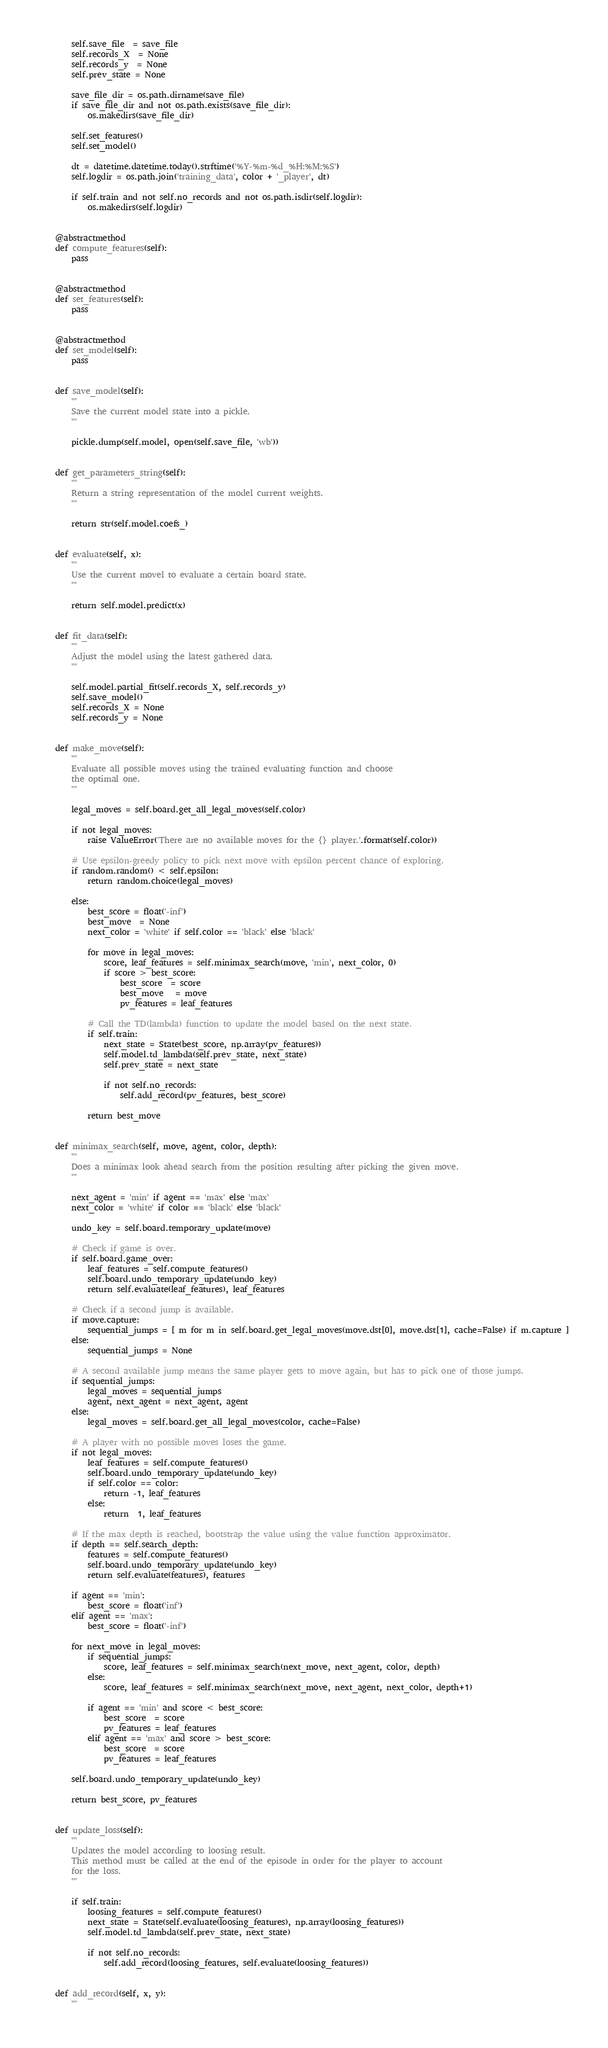<code> <loc_0><loc_0><loc_500><loc_500><_Python_>        self.save_file  = save_file
        self.records_X  = None
        self.records_y  = None
        self.prev_state = None

        save_file_dir = os.path.dirname(save_file)
        if save_file_dir and not os.path.exists(save_file_dir):
            os.makedirs(save_file_dir)

        self.set_features()
        self.set_model()

        dt = datetime.datetime.today().strftime('%Y-%m-%d_%H:%M:%S')
        self.logdir = os.path.join('training_data', color + '_player', dt)

        if self.train and not self.no_records and not os.path.isdir(self.logdir):
            os.makedirs(self.logdir)


    @abstractmethod
    def compute_features(self):
        pass

    
    @abstractmethod
    def set_features(self):
        pass


    @abstractmethod
    def set_model(self):
        pass 


    def save_model(self):
        '''
        Save the current model state into a pickle.
        '''

        pickle.dump(self.model, open(self.save_file, 'wb'))


    def get_parameters_string(self):
        '''
        Return a string representation of the model current weights.
        '''

        return str(self.model.coefs_)


    def evaluate(self, x):
        '''
        Use the current movel to evaluate a certain board state.
        '''

        return self.model.predict(x)


    def fit_data(self):
        '''
        Adjust the model using the latest gathered data.
        '''

        self.model.partial_fit(self.records_X, self.records_y)
        self.save_model()
        self.records_X = None
        self.records_y = None


    def make_move(self):
        '''
        Evaluate all possible moves using the trained evaluating function and choose
        the optimal one.
        '''

        legal_moves = self.board.get_all_legal_moves(self.color)

        if not legal_moves:
            raise ValueError('There are no available moves for the {} player.'.format(self.color))

        # Use epsilon-greedy policy to pick next move with epsilon percent chance of exploring. 
        if random.random() < self.epsilon:
            return random.choice(legal_moves)

        else:
            best_score = float('-inf')
            best_move  = None
            next_color = 'white' if self.color == 'black' else 'black'

            for move in legal_moves:
                score, leaf_features = self.minimax_search(move, 'min', next_color, 0)
                if score > best_score:
                    best_score  = score
                    best_move   = move
                    pv_features = leaf_features

            # Call the TD(lambda) function to update the model based on the next state.
            if self.train:
                next_state = State(best_score, np.array(pv_features))
                self.model.td_lambda(self.prev_state, next_state)
                self.prev_state = next_state

                if not self.no_records:
                    self.add_record(pv_features, best_score)

            return best_move


    def minimax_search(self, move, agent, color, depth):
        '''
        Does a minimax look ahead search from the position resulting after picking the given move.
        '''

        next_agent = 'min' if agent == 'max' else 'max'
        next_color = 'white' if color == 'black' else 'black'

        undo_key = self.board.temporary_update(move)

        # Check if game is over.
        if self.board.game_over:
            leaf_features = self.compute_features()
            self.board.undo_temporary_update(undo_key)
            return self.evaluate(leaf_features), leaf_features

        # Check if a second jump is available.
        if move.capture:
            sequential_jumps = [ m for m in self.board.get_legal_moves(move.dst[0], move.dst[1], cache=False) if m.capture ]
        else:
            sequential_jumps = None

        # A second available jump means the same player gets to move again, but has to pick one of those jumps.
        if sequential_jumps:
            legal_moves = sequential_jumps
            agent, next_agent = next_agent, agent
        else:
            legal_moves = self.board.get_all_legal_moves(color, cache=False)

        # A player with no possible moves loses the game.
        if not legal_moves:
            leaf_features = self.compute_features()
            self.board.undo_temporary_update(undo_key)
            if self.color == color:
                return -1, leaf_features
            else:
                return  1, leaf_features

        # If the max depth is reached, bootstrap the value using the value function approximator.
        if depth == self.search_depth:
            features = self.compute_features()
            self.board.undo_temporary_update(undo_key)
            return self.evaluate(features), features

        if agent == 'min':
            best_score = float('inf')
        elif agent == 'max':
            best_score = float('-inf')

        for next_move in legal_moves:
            if sequential_jumps:
                score, leaf_features = self.minimax_search(next_move, next_agent, color, depth)
            else:
                score, leaf_features = self.minimax_search(next_move, next_agent, next_color, depth+1)

            if agent == 'min' and score < best_score:
                best_score  = score
                pv_features = leaf_features
            elif agent == 'max' and score > best_score:
                best_score  = score
                pv_features = leaf_features

        self.board.undo_temporary_update(undo_key)

        return best_score, pv_features


    def update_loss(self):
        '''
        Updates the model according to loosing result.
        This method must be called at the end of the episode in order for the player to account
        for the loss.
        '''

        if self.train:
            loosing_features = self.compute_features()
            next_state = State(self.evaluate(loosing_features), np.array(loosing_features))
            self.model.td_lambda(self.prev_state, next_state)

            if not self.no_records:
                self.add_record(loosing_features, self.evaluate(loosing_features))
             

    def add_record(self, x, y):
        '''</code> 